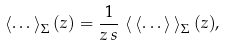<formula> <loc_0><loc_0><loc_500><loc_500>\left \langle \dots \right \rangle _ { \Sigma } ( z ) = \frac { 1 } { z \, s } \, \left \langle \, \left \langle \dots \right \rangle \, \right \rangle _ { \Sigma } ( z ) ,</formula> 